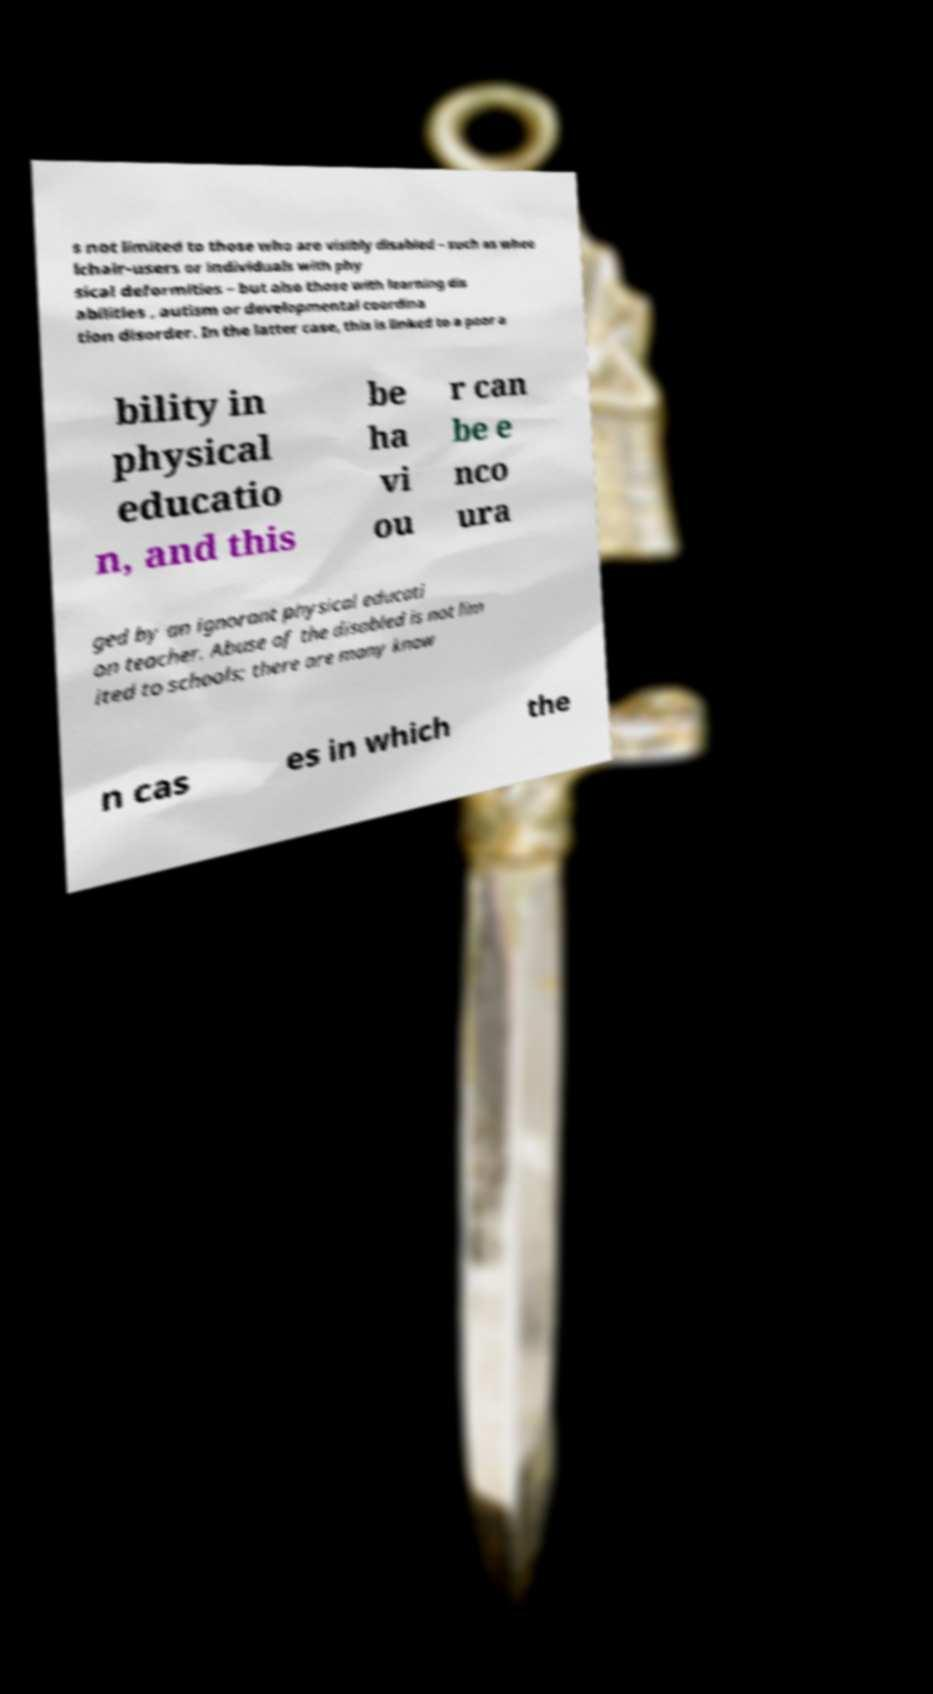Please read and relay the text visible in this image. What does it say? s not limited to those who are visibly disabled – such as whee lchair-users or individuals with phy sical deformities – but also those with learning dis abilities , autism or developmental coordina tion disorder. In the latter case, this is linked to a poor a bility in physical educatio n, and this be ha vi ou r can be e nco ura ged by an ignorant physical educati on teacher. Abuse of the disabled is not lim ited to schools; there are many know n cas es in which the 